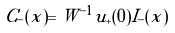Convert formula to latex. <formula><loc_0><loc_0><loc_500><loc_500>C _ { - } ( x ) = W ^ { - 1 } u _ { + } ( 0 ) I _ { - } ( x )</formula> 